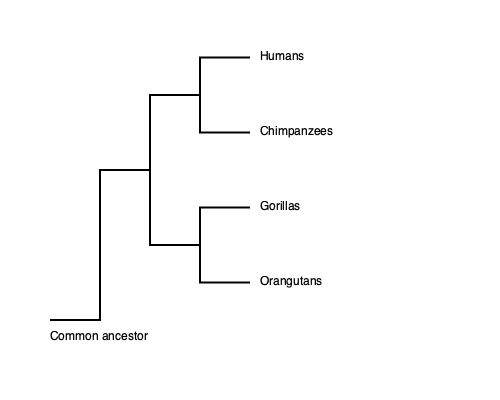Based on the evolutionary tree of primates shown, which great ape species is most closely related to humans, and approximately how many million years ago did they share a common ancestor? To answer this question, we need to analyze the evolutionary tree and apply our knowledge of evolutionary biology:

1. The tree shows the evolutionary relationships between humans and three great ape species: chimpanzees, gorillas, and orangutans.

2. The branching points (nodes) represent common ancestors, and the length of the branches indicates the time since divergence.

3. Humans and chimpanzees share the most recent common ancestor, as their branches split off later than the others.

4. The next closest relative is the gorilla, followed by the orangutan.

5. To estimate the time since the last common ancestor of humans and chimpanzees, we need to consider recent genetic and fossil evidence:

   a. Genetic studies suggest that humans and chimpanzees diverged between 5 and 7 million years ago.
   b. Fossil evidence, including discoveries like Sahelanthropus tchadensis, supports this timeframe.

6. The most widely accepted estimate for the human-chimpanzee divergence is approximately 6 million years ago.

This evolutionary relationship is supported by genetic evidence, which shows that humans and chimpanzees share about 98-99% of their DNA.
Answer: Chimpanzees, approximately 6 million years ago. 